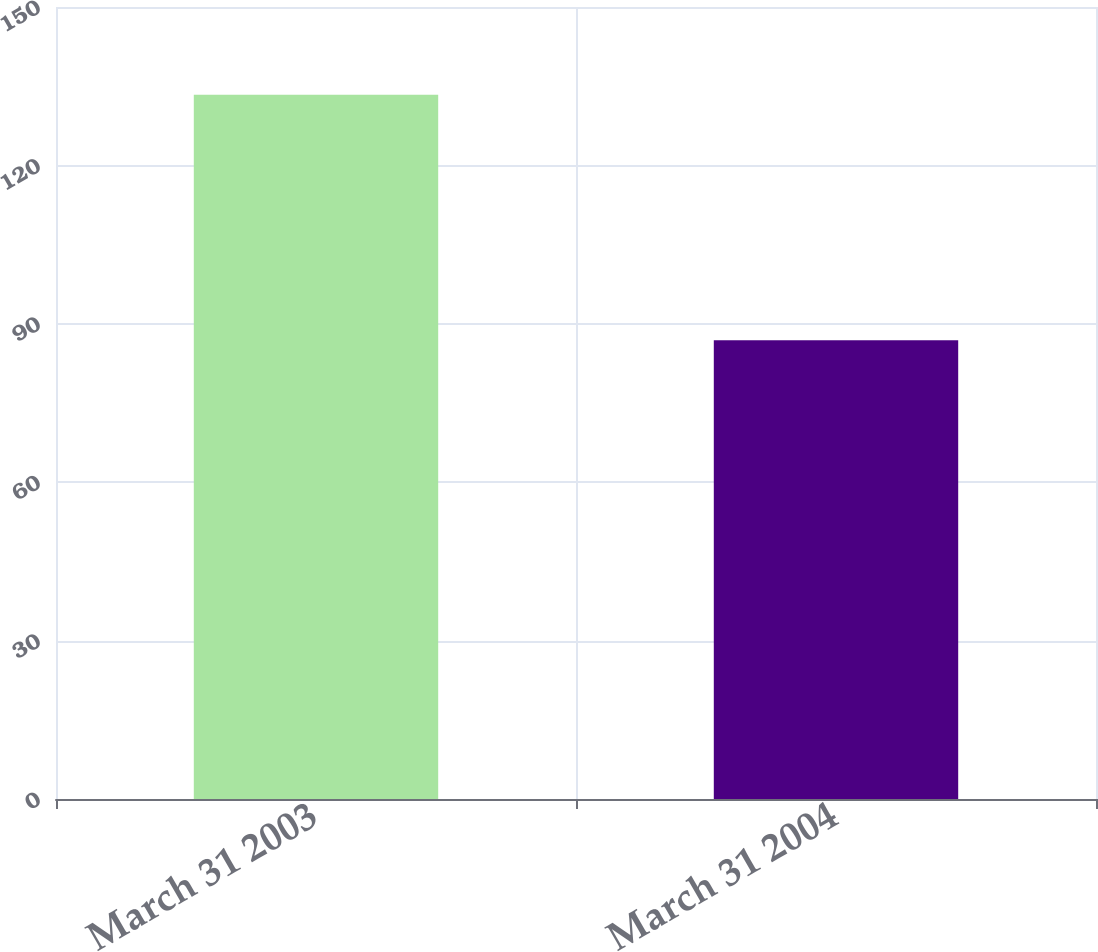Convert chart. <chart><loc_0><loc_0><loc_500><loc_500><bar_chart><fcel>March 31 2003<fcel>March 31 2004<nl><fcel>133.4<fcel>86.9<nl></chart> 